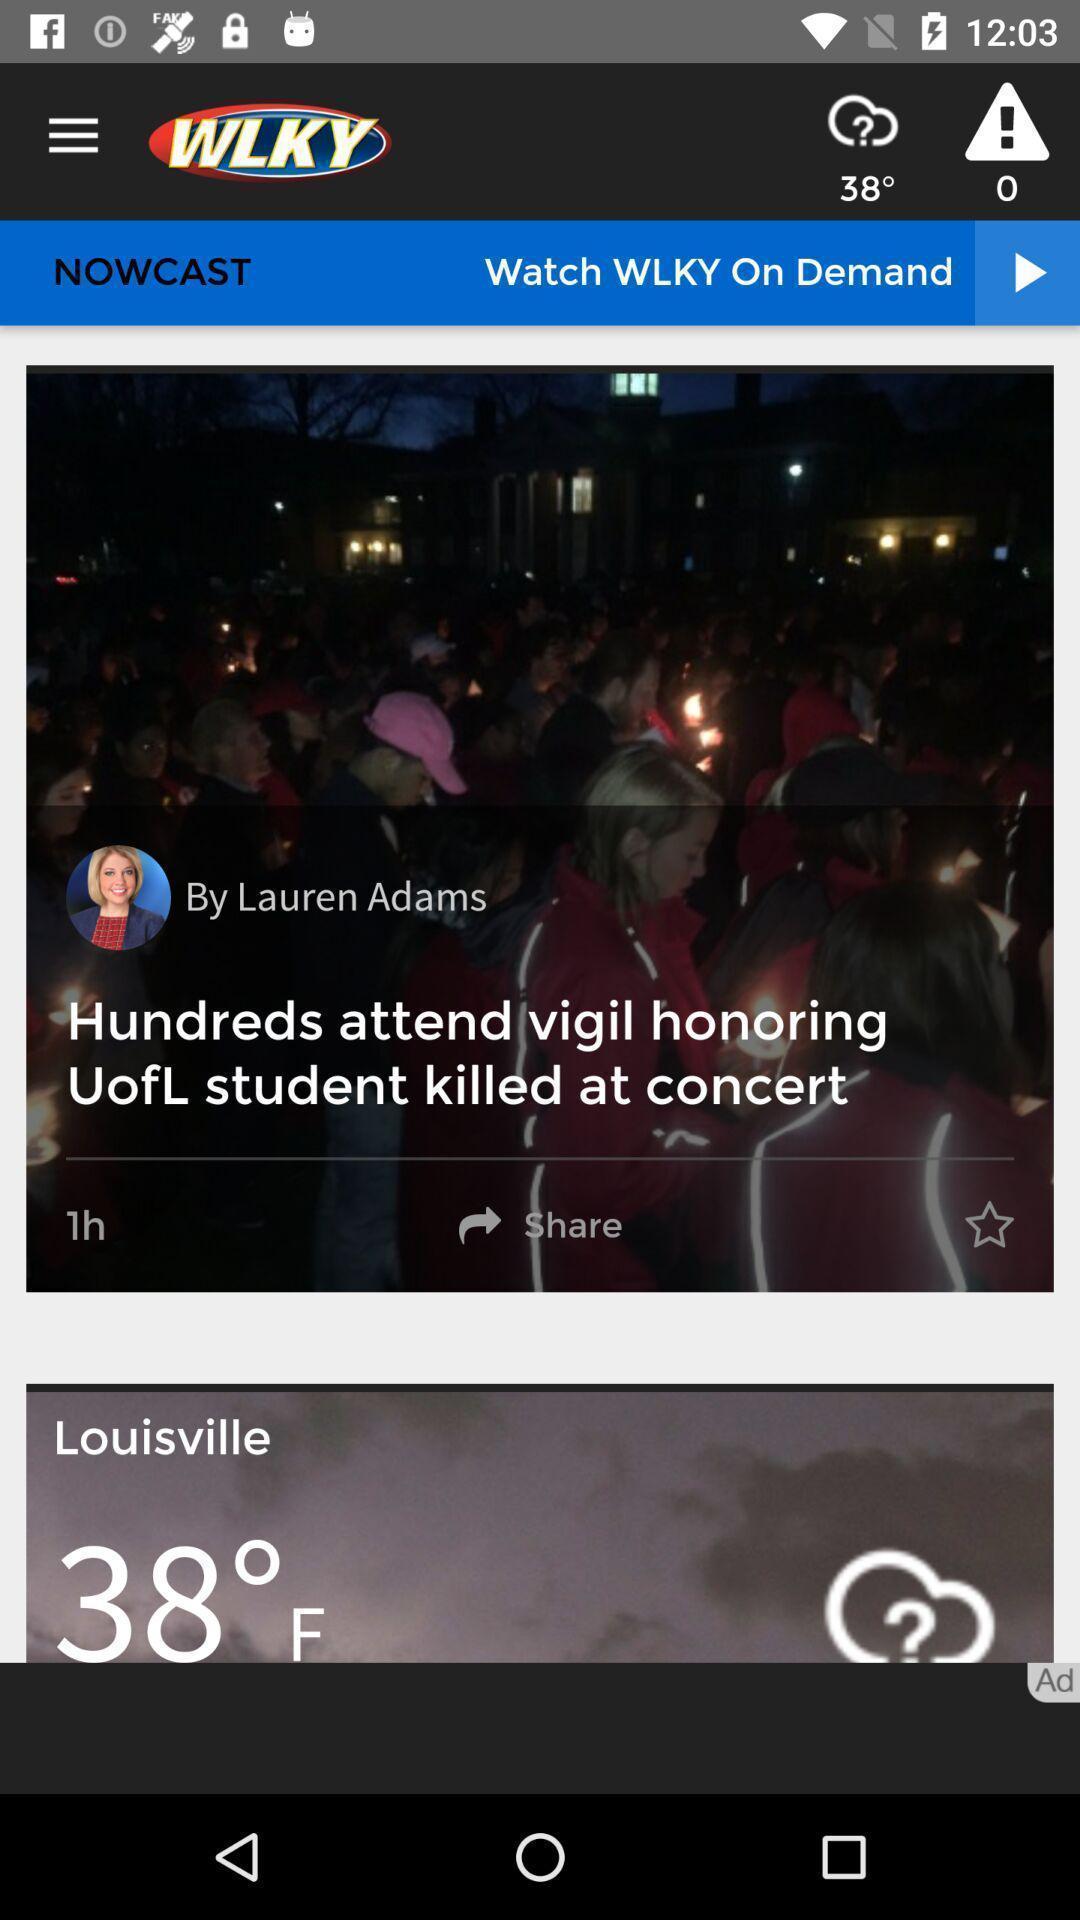Summarize the information in this screenshot. Window displaying a news app. 